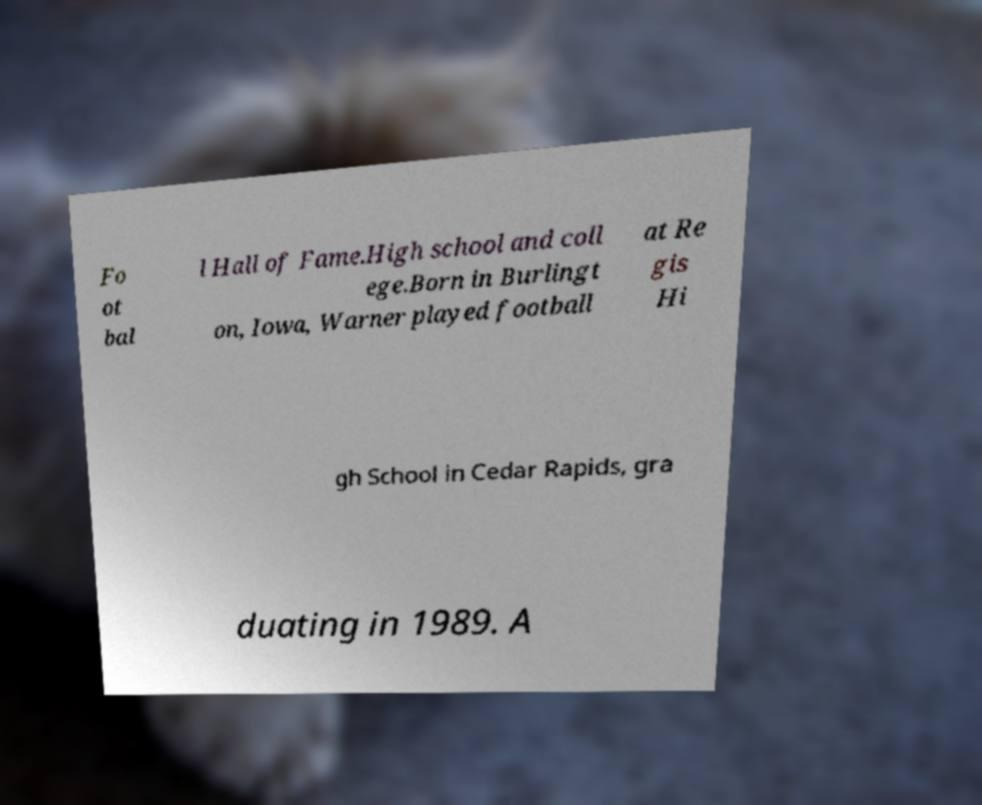Can you read and provide the text displayed in the image?This photo seems to have some interesting text. Can you extract and type it out for me? Fo ot bal l Hall of Fame.High school and coll ege.Born in Burlingt on, Iowa, Warner played football at Re gis Hi gh School in Cedar Rapids, gra duating in 1989. A 